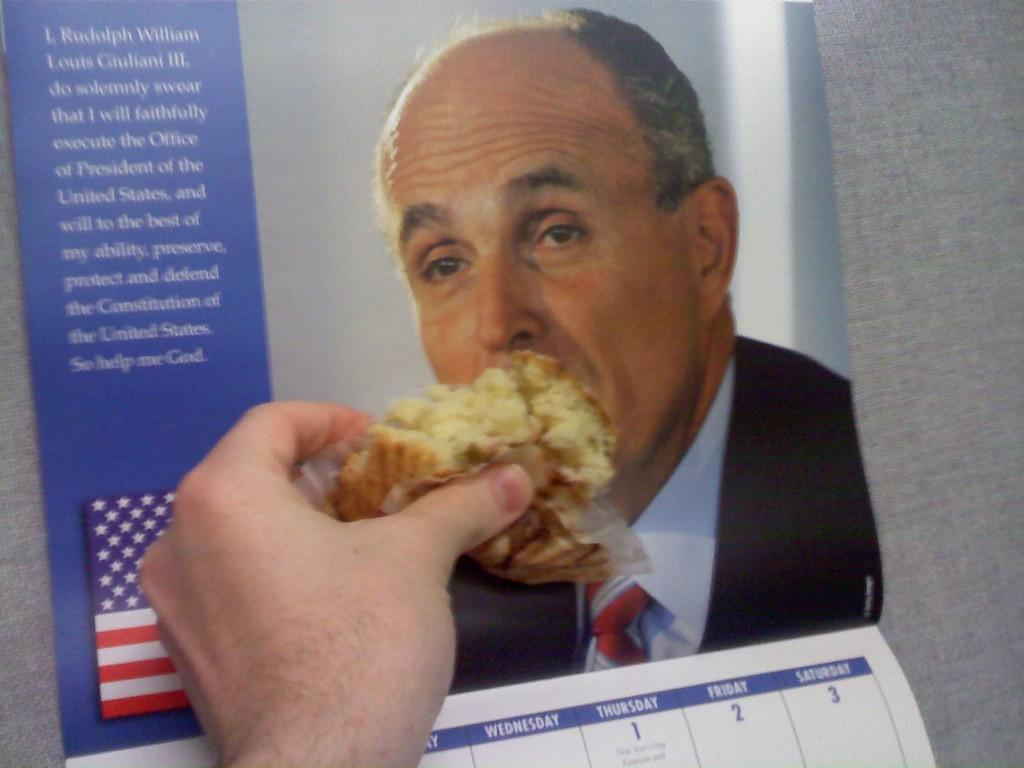What is the main object in the center of the image? There is a calendar in the center of the image. What is featured on the calendar? There is a photograph on the calendar. What is the person in the image holding? The person in the image is holding a cake. Where is the cake placed in the image? The cake is placed on the calendar. What type of haircut does the kitty have in the image? There is no kitty present in the image, so it is not possible to determine the type of haircut it might have. 